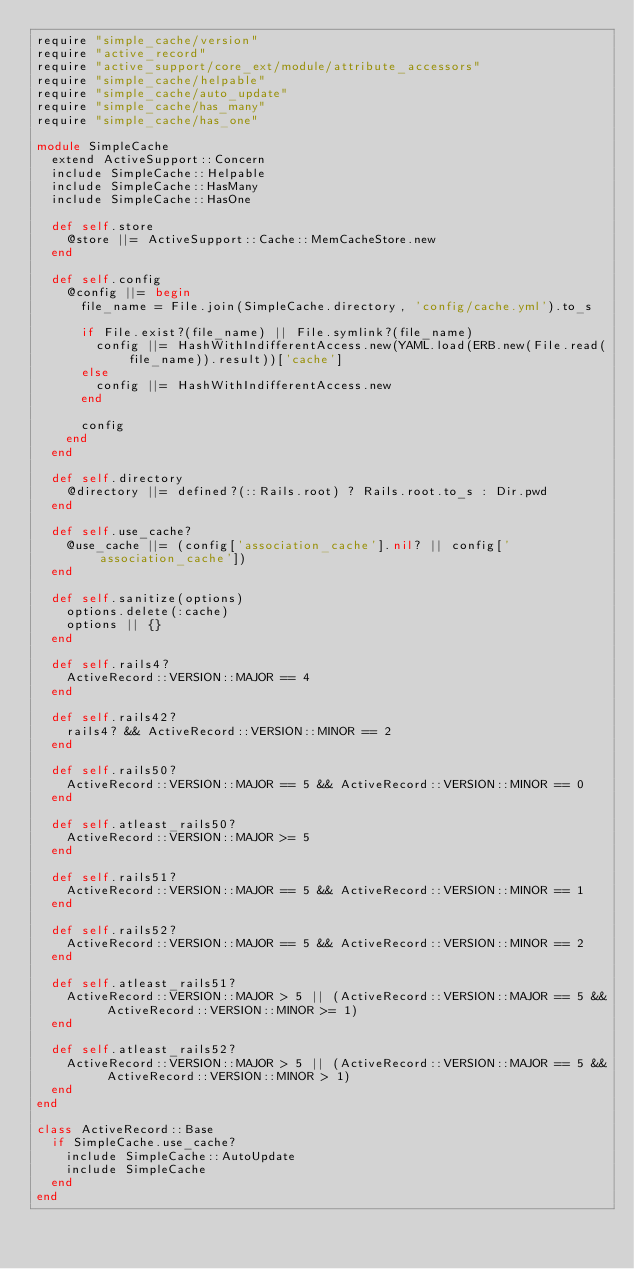Convert code to text. <code><loc_0><loc_0><loc_500><loc_500><_Ruby_>require "simple_cache/version"
require "active_record"
require "active_support/core_ext/module/attribute_accessors"
require "simple_cache/helpable"
require "simple_cache/auto_update"
require "simple_cache/has_many"
require "simple_cache/has_one"

module SimpleCache
  extend ActiveSupport::Concern
  include SimpleCache::Helpable
  include SimpleCache::HasMany
  include SimpleCache::HasOne

  def self.store 
    @store ||= ActiveSupport::Cache::MemCacheStore.new  
  end

  def self.config
    @config ||= begin
      file_name = File.join(SimpleCache.directory, 'config/cache.yml').to_s

      if File.exist?(file_name) || File.symlink?(file_name)
        config ||= HashWithIndifferentAccess.new(YAML.load(ERB.new(File.read(file_name)).result))['cache']
      else
        config ||= HashWithIndifferentAccess.new
      end

      config
    end
  end

  def self.directory
    @directory ||= defined?(::Rails.root) ? Rails.root.to_s : Dir.pwd
  end

  def self.use_cache?
    @use_cache ||= (config['association_cache'].nil? || config['association_cache'])
  end

  def self.sanitize(options)
    options.delete(:cache)
    options || {}
  end

  def self.rails4?
    ActiveRecord::VERSION::MAJOR == 4
  end

  def self.rails42?
    rails4? && ActiveRecord::VERSION::MINOR == 2
  end

  def self.rails50?
    ActiveRecord::VERSION::MAJOR == 5 && ActiveRecord::VERSION::MINOR == 0
  end
  
  def self.atleast_rails50?
    ActiveRecord::VERSION::MAJOR >= 5
  end

  def self.rails51?
    ActiveRecord::VERSION::MAJOR == 5 && ActiveRecord::VERSION::MINOR == 1
  end

  def self.rails52?
    ActiveRecord::VERSION::MAJOR == 5 && ActiveRecord::VERSION::MINOR == 2
  end

  def self.atleast_rails51?
    ActiveRecord::VERSION::MAJOR > 5 || (ActiveRecord::VERSION::MAJOR == 5 && ActiveRecord::VERSION::MINOR >= 1)
  end

  def self.atleast_rails52?
    ActiveRecord::VERSION::MAJOR > 5 || (ActiveRecord::VERSION::MAJOR == 5 && ActiveRecord::VERSION::MINOR > 1)
  end
end

class ActiveRecord::Base 
  if SimpleCache.use_cache?
    include SimpleCache::AutoUpdate
    include SimpleCache
  end
end</code> 